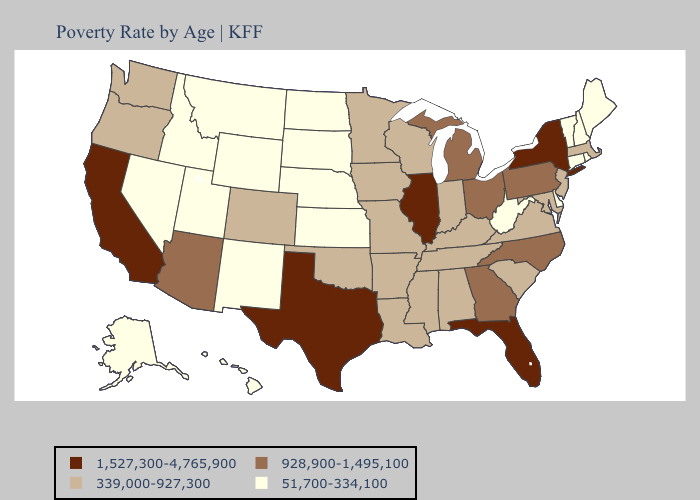What is the highest value in states that border Mississippi?
Give a very brief answer. 339,000-927,300. Does Illinois have the lowest value in the USA?
Give a very brief answer. No. Which states have the lowest value in the USA?
Give a very brief answer. Alaska, Connecticut, Delaware, Hawaii, Idaho, Kansas, Maine, Montana, Nebraska, Nevada, New Hampshire, New Mexico, North Dakota, Rhode Island, South Dakota, Utah, Vermont, West Virginia, Wyoming. Does Utah have a higher value than South Dakota?
Concise answer only. No. Which states have the lowest value in the USA?
Quick response, please. Alaska, Connecticut, Delaware, Hawaii, Idaho, Kansas, Maine, Montana, Nebraska, Nevada, New Hampshire, New Mexico, North Dakota, Rhode Island, South Dakota, Utah, Vermont, West Virginia, Wyoming. Among the states that border Missouri , does Illinois have the highest value?
Write a very short answer. Yes. What is the value of Tennessee?
Be succinct. 339,000-927,300. Does Texas have the highest value in the USA?
Be succinct. Yes. What is the value of Montana?
Short answer required. 51,700-334,100. Does the map have missing data?
Be succinct. No. Does the map have missing data?
Short answer required. No. Does Delaware have the lowest value in the USA?
Quick response, please. Yes. What is the highest value in the USA?
Concise answer only. 1,527,300-4,765,900. What is the highest value in the Northeast ?
Concise answer only. 1,527,300-4,765,900. What is the value of West Virginia?
Answer briefly. 51,700-334,100. 